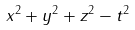<formula> <loc_0><loc_0><loc_500><loc_500>x ^ { 2 } + y ^ { 2 } + z ^ { 2 } - t ^ { 2 }</formula> 